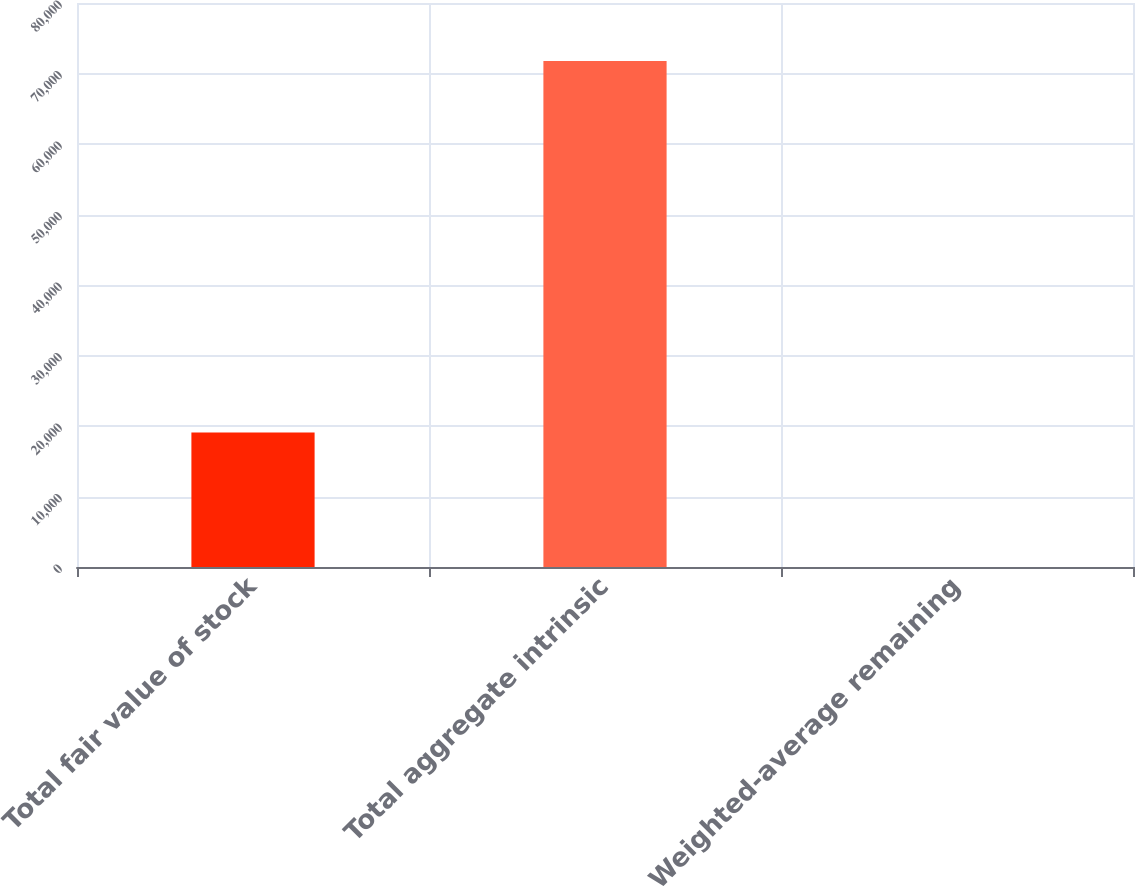<chart> <loc_0><loc_0><loc_500><loc_500><bar_chart><fcel>Total fair value of stock<fcel>Total aggregate intrinsic<fcel>Weighted-average remaining<nl><fcel>19066<fcel>71783<fcel>3.87<nl></chart> 